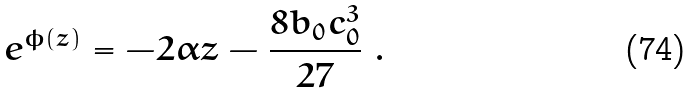Convert formula to latex. <formula><loc_0><loc_0><loc_500><loc_500>e ^ { \phi ( z ) } = - 2 \alpha z - \frac { 8 b _ { 0 } c _ { 0 } ^ { 3 } } { 2 7 } \ .</formula> 